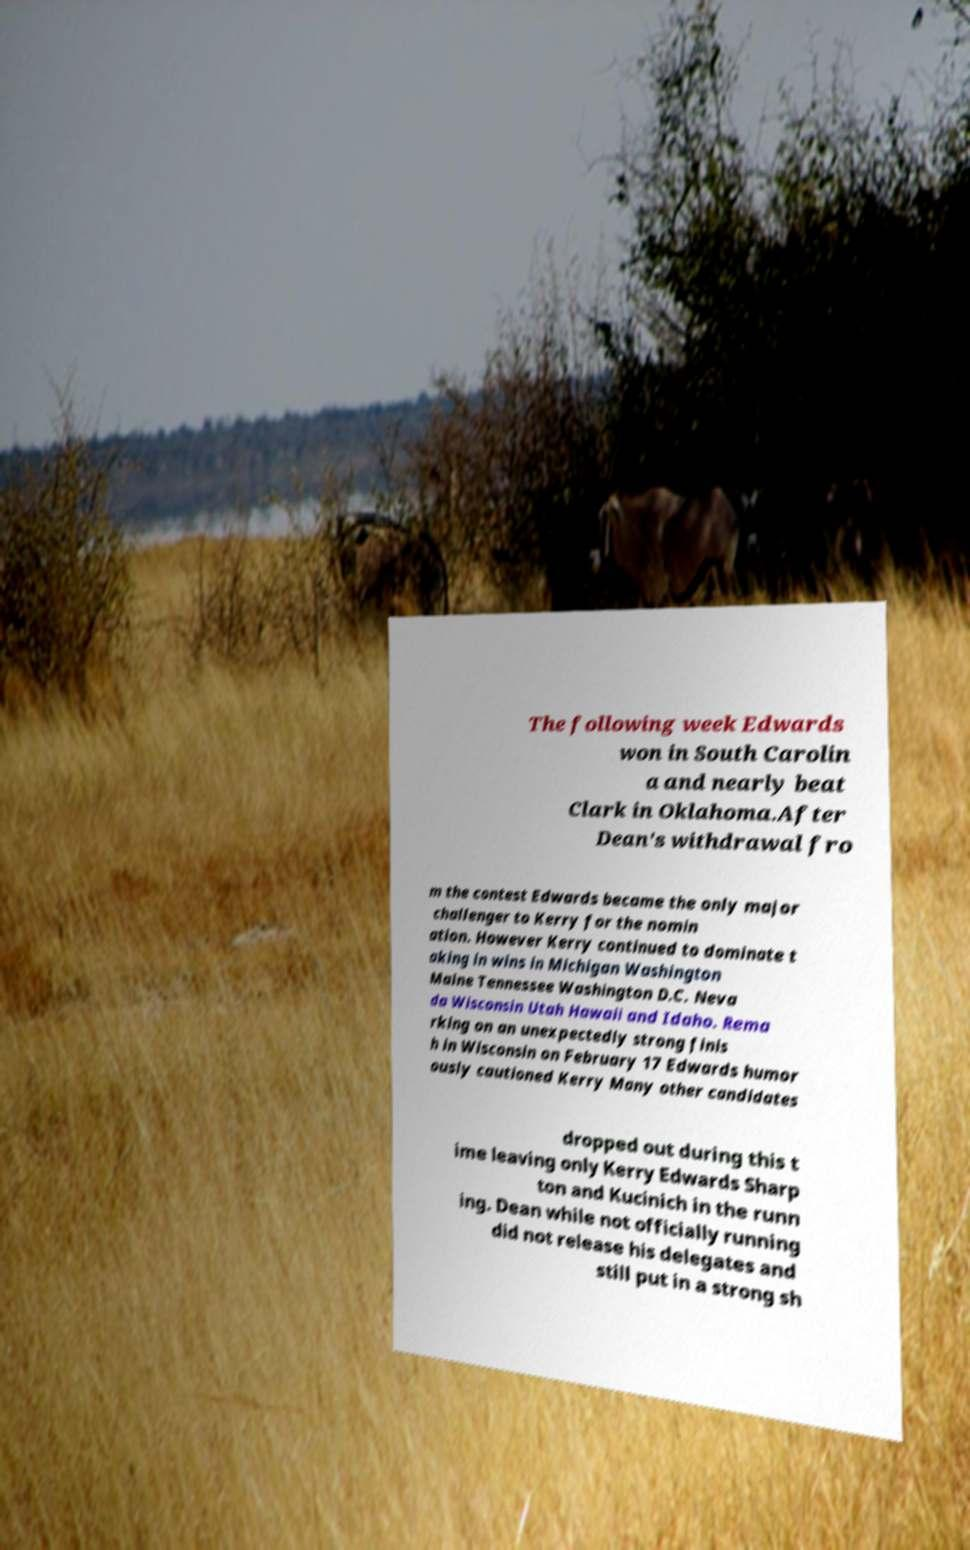I need the written content from this picture converted into text. Can you do that? The following week Edwards won in South Carolin a and nearly beat Clark in Oklahoma.After Dean's withdrawal fro m the contest Edwards became the only major challenger to Kerry for the nomin ation. However Kerry continued to dominate t aking in wins in Michigan Washington Maine Tennessee Washington D.C. Neva da Wisconsin Utah Hawaii and Idaho. Rema rking on an unexpectedly strong finis h in Wisconsin on February 17 Edwards humor ously cautioned Kerry Many other candidates dropped out during this t ime leaving only Kerry Edwards Sharp ton and Kucinich in the runn ing. Dean while not officially running did not release his delegates and still put in a strong sh 